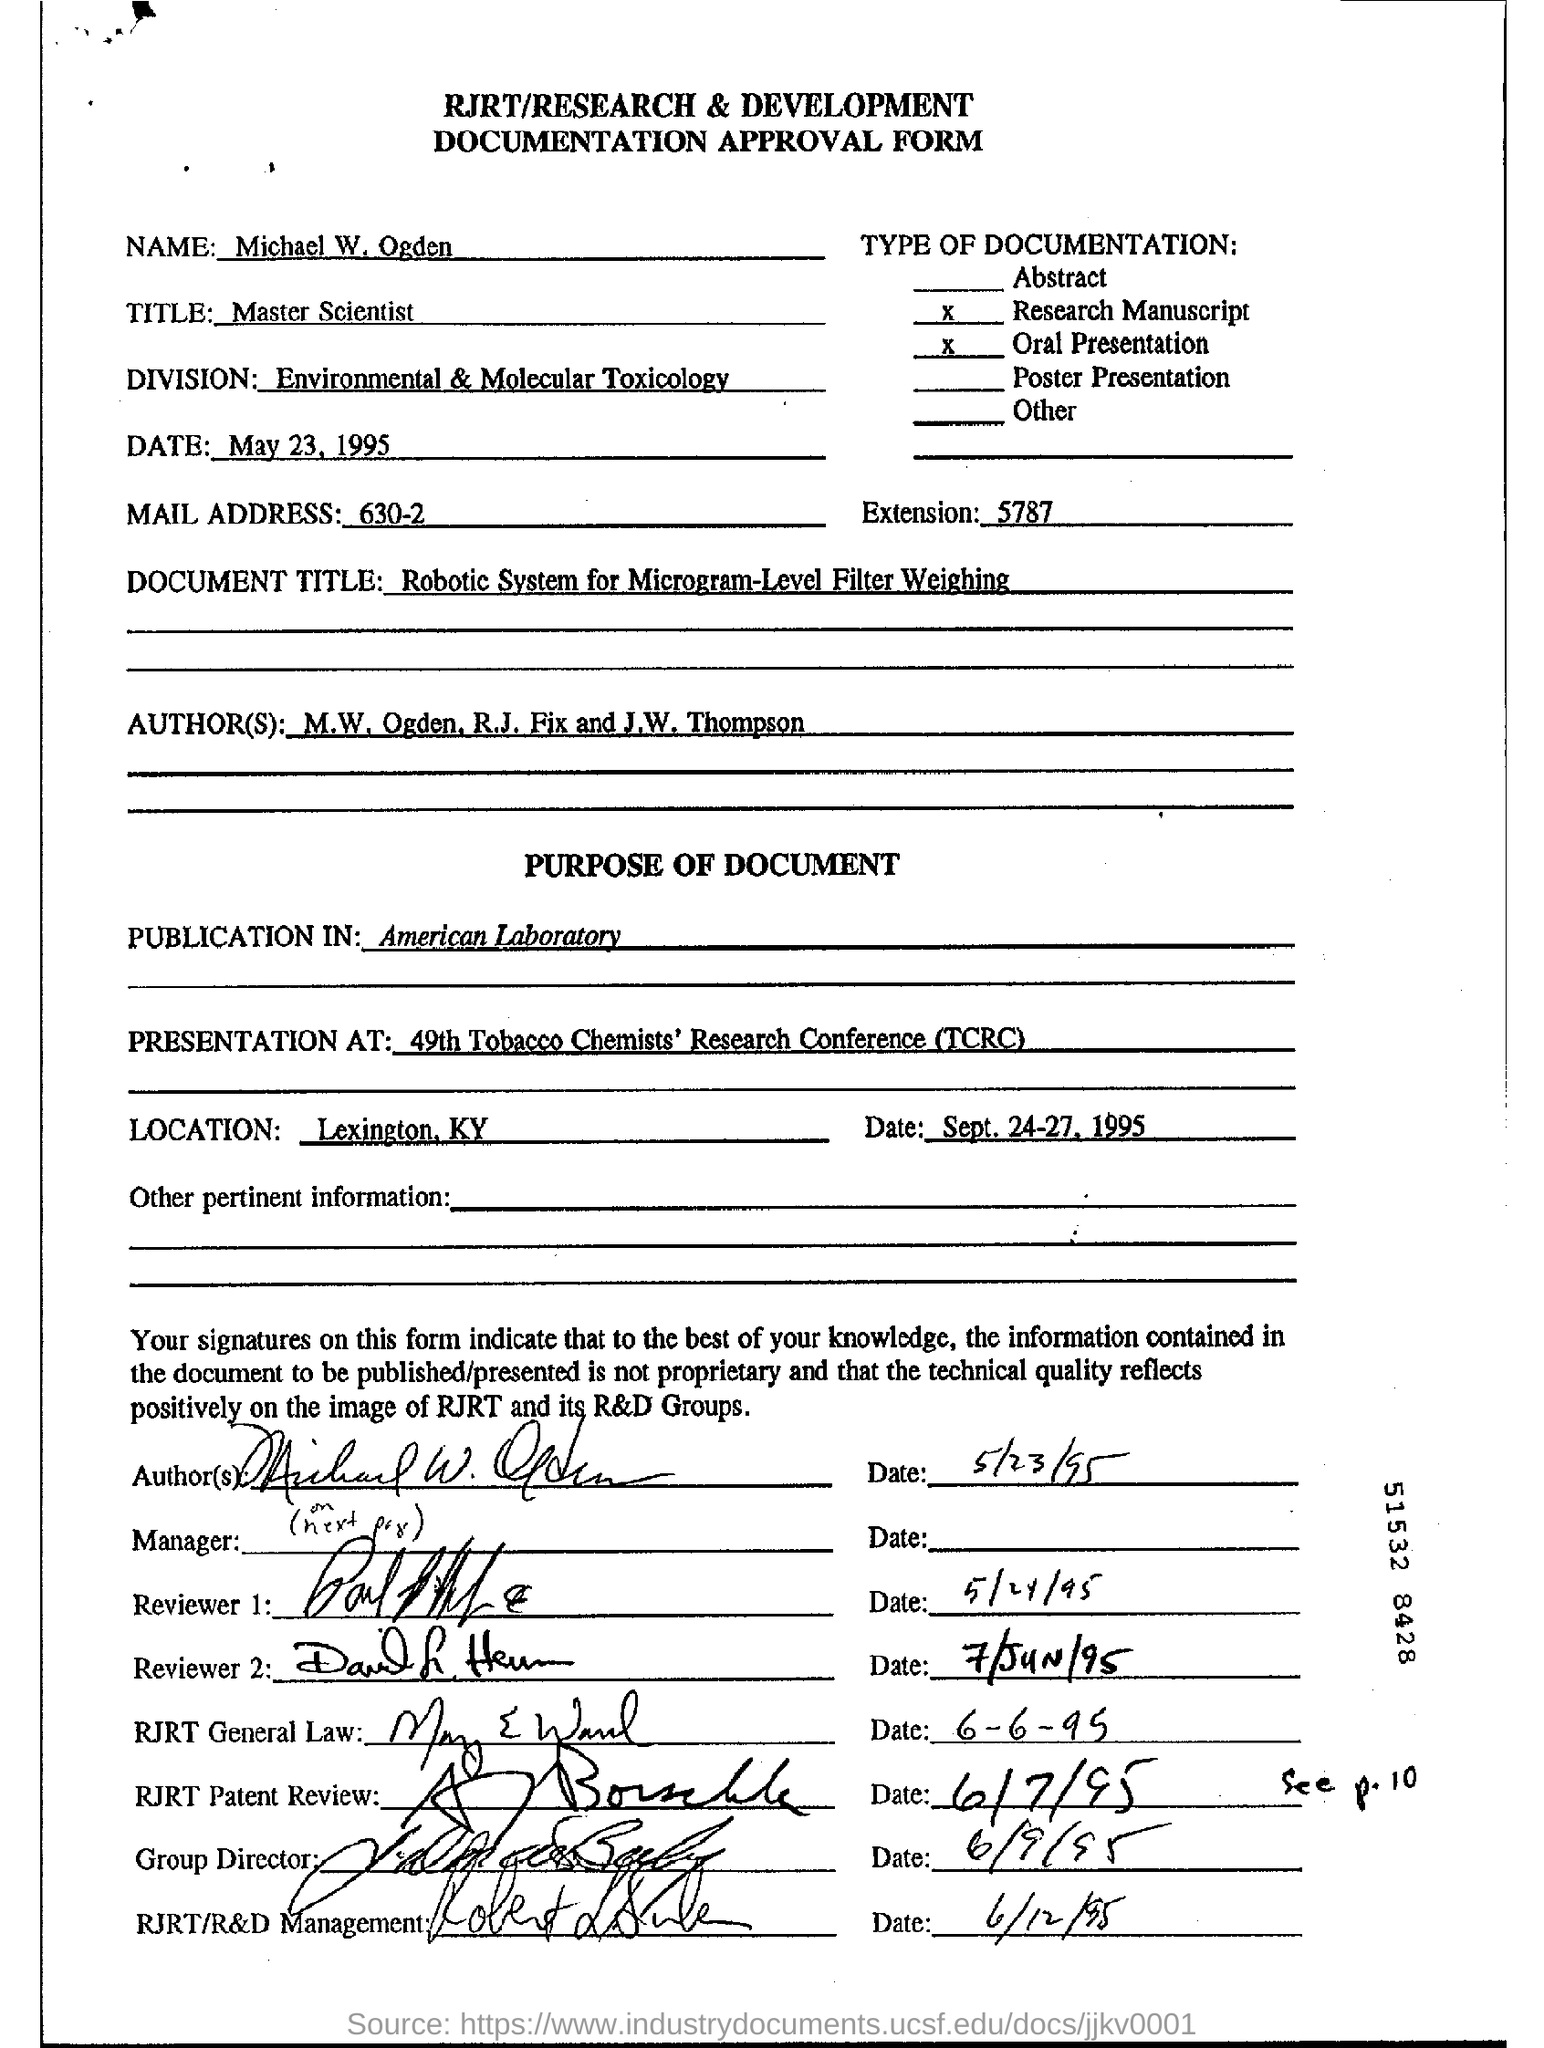What is the job title of Michael W. Ogden?
Make the answer very short. Master scientist. Which division is Michael W. Ogden part of?
Your answer should be very brief. Environmental & molecular toxicology. What is the "TITLE"?
Provide a short and direct response. Master Scientist. What is the "document title"?
Keep it short and to the point. Robotic system for Microgram-level Filter Weighing. Who are the authors of the paper?
Ensure brevity in your answer.  M.W. Ogden , R.J. Fix and J.W. Thompson. Where was the document published?
Offer a very short reply. American Laboratory. What does TCRC stand for?
Offer a very short reply. Tobacco Chemists' Research Conference. Where is the location of the 49th TCRC?
Keep it short and to the point. Lexington, KY. 